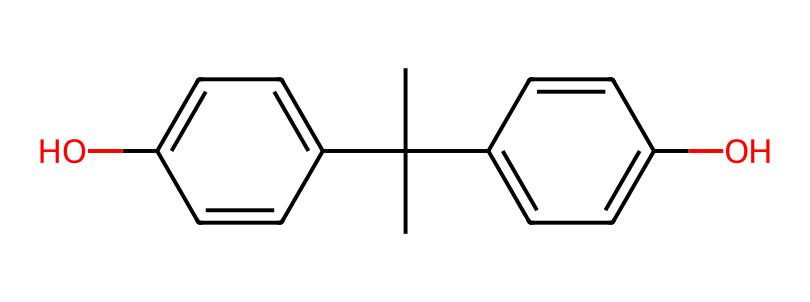What is the molecular formula of bisphenol A? By deducing the number of carbon (C), hydrogen (H), and oxygen (O) atoms from the SMILES notation, we can determine the molecular formula. The SMILES shows there are 15 carbon atoms, 16 hydrogen atoms, and 2 oxygen atoms. Therefore, the formula is C15H16O2.
Answer: C15H16O2 How many hydroxyl (−OH) groups are present in bisphenol A? The structure includes two phenolic groups, each containing a hydroxyl (−OH) group. Therefore, there are two hydroxyl groups.
Answer: 2 What type of bonding is primarily found in bisphenol A? The primary type of bonding in bisphenol A is covalent bonding, as it predominantly comprises non-metal atoms sharing electrons.
Answer: covalent Which functional groups are present in the structure of bisphenol A? Analyzing the structure shows the presence of two hydroxyl (−OH) groups and phenolic (aromatic) groups. Therefore, the functional groups are hydroxyl and phenolic.
Answer: hydroxyl and phenolic What is the total number of rings in the bisphenol A structure? Bisphenol A has two phenolic groups, each comprising a benzene ring. Therefore, the total number of rings is two.
Answer: 2 Does bisphenol A have any double bonds? Inspecting the chemical structure reveals the presence of double bonds within the aromatic rings. Thus, yes, bisphenol A contains double bonds.
Answer: yes 